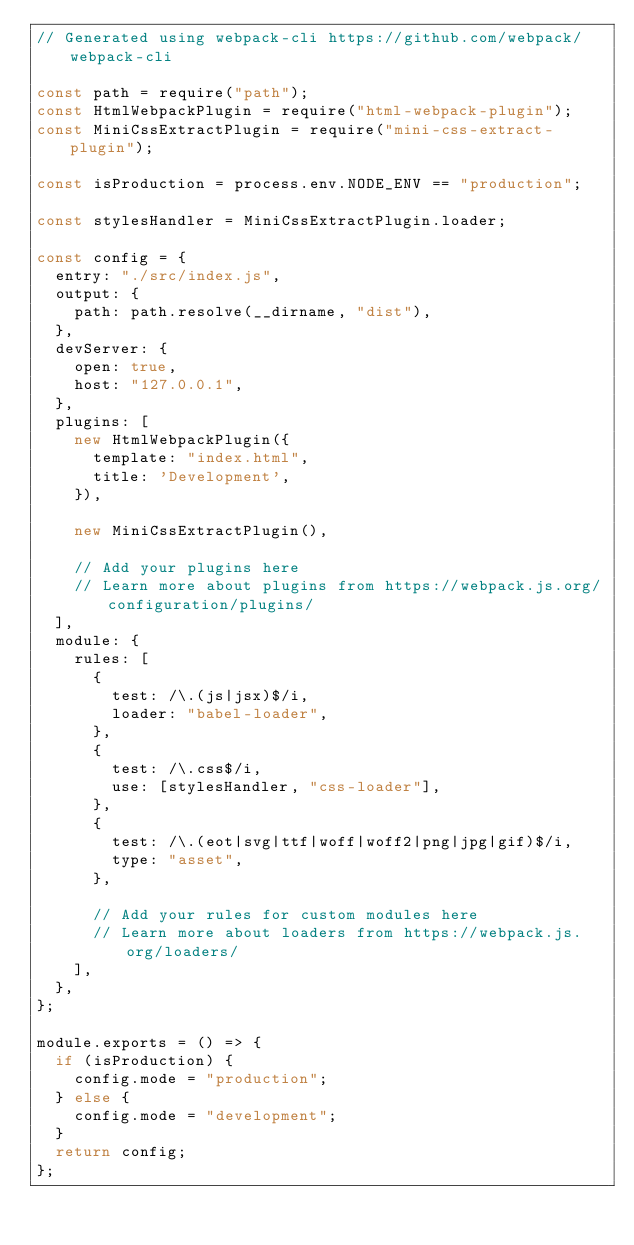Convert code to text. <code><loc_0><loc_0><loc_500><loc_500><_JavaScript_>// Generated using webpack-cli https://github.com/webpack/webpack-cli

const path = require("path");
const HtmlWebpackPlugin = require("html-webpack-plugin");
const MiniCssExtractPlugin = require("mini-css-extract-plugin");

const isProduction = process.env.NODE_ENV == "production";

const stylesHandler = MiniCssExtractPlugin.loader;

const config = {
  entry: "./src/index.js",
  output: {
    path: path.resolve(__dirname, "dist"),
  },
  devServer: {
    open: true,
    host: "127.0.0.1",
  },
  plugins: [
    new HtmlWebpackPlugin({
      template: "index.html",
      title: 'Development',
    }),

    new MiniCssExtractPlugin(),

    // Add your plugins here
    // Learn more about plugins from https://webpack.js.org/configuration/plugins/
  ],
  module: {
    rules: [
      {
        test: /\.(js|jsx)$/i,
        loader: "babel-loader",
      },
      {
        test: /\.css$/i,
        use: [stylesHandler, "css-loader"],
      },
      {
        test: /\.(eot|svg|ttf|woff|woff2|png|jpg|gif)$/i,
        type: "asset",
      },

      // Add your rules for custom modules here
      // Learn more about loaders from https://webpack.js.org/loaders/
    ],
  },
};

module.exports = () => {
  if (isProduction) {
    config.mode = "production";
  } else {
    config.mode = "development";
  }
  return config;
};
</code> 